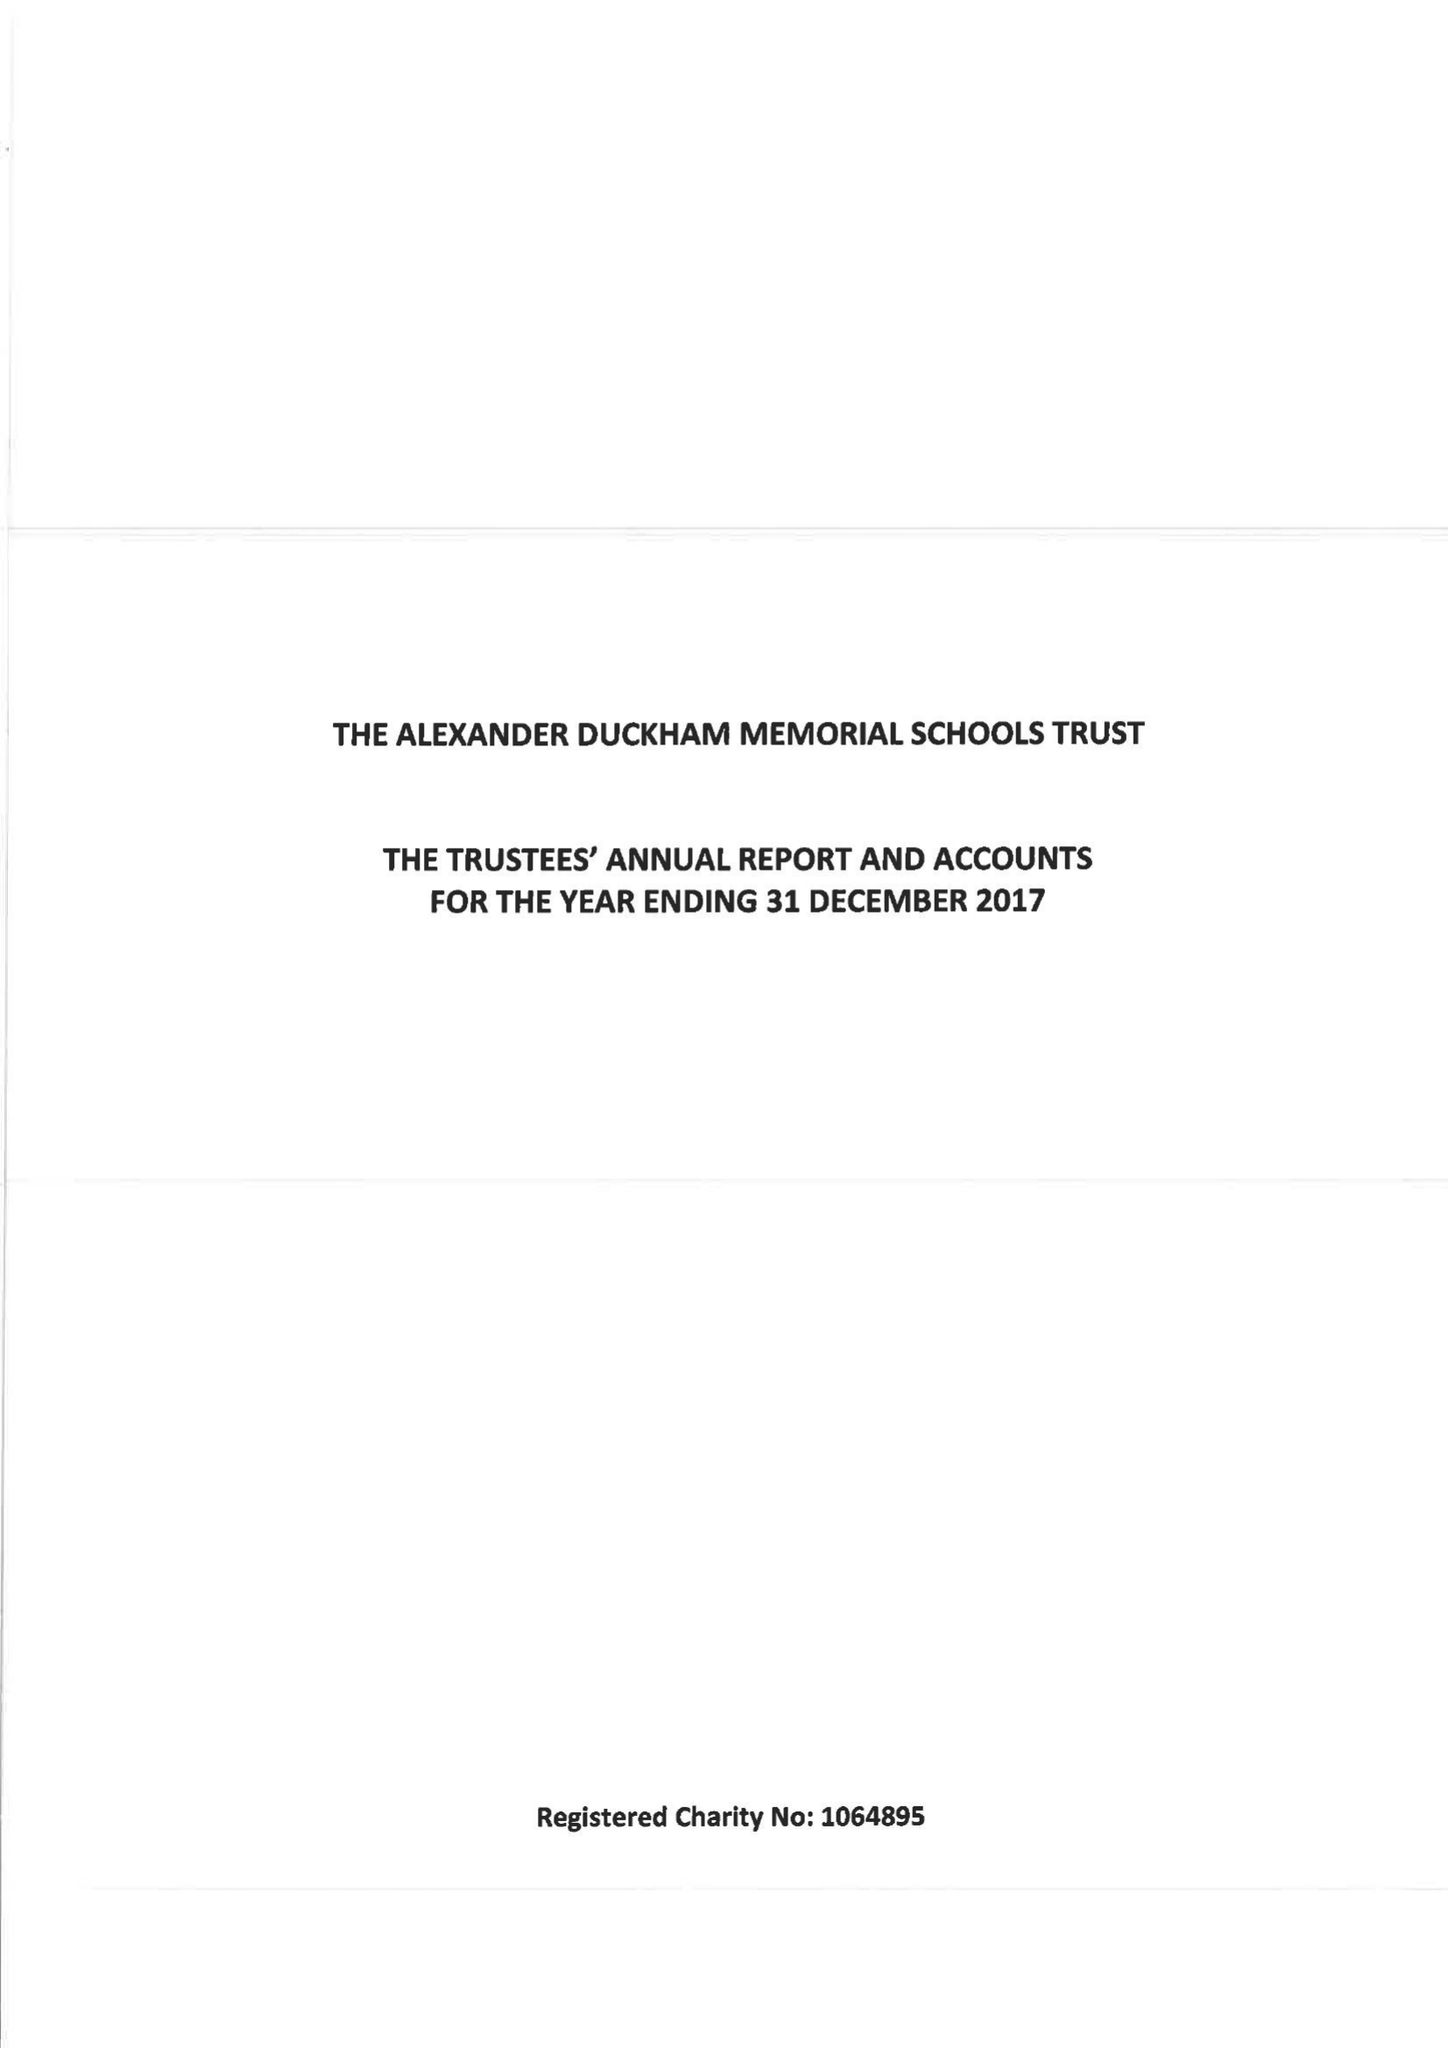What is the value for the spending_annually_in_british_pounds?
Answer the question using a single word or phrase. 159646.00 